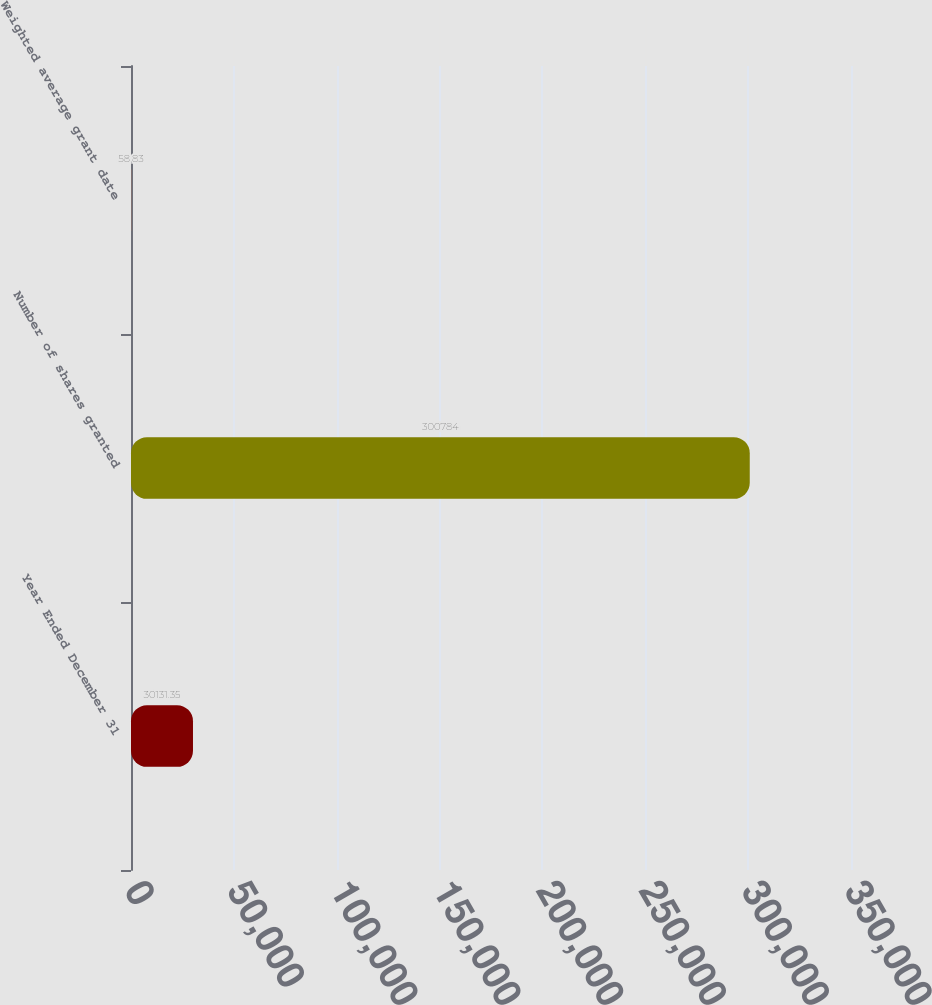Convert chart to OTSL. <chart><loc_0><loc_0><loc_500><loc_500><bar_chart><fcel>Year Ended December 31<fcel>Number of shares granted<fcel>Weighted average grant date<nl><fcel>30131.3<fcel>300784<fcel>58.83<nl></chart> 